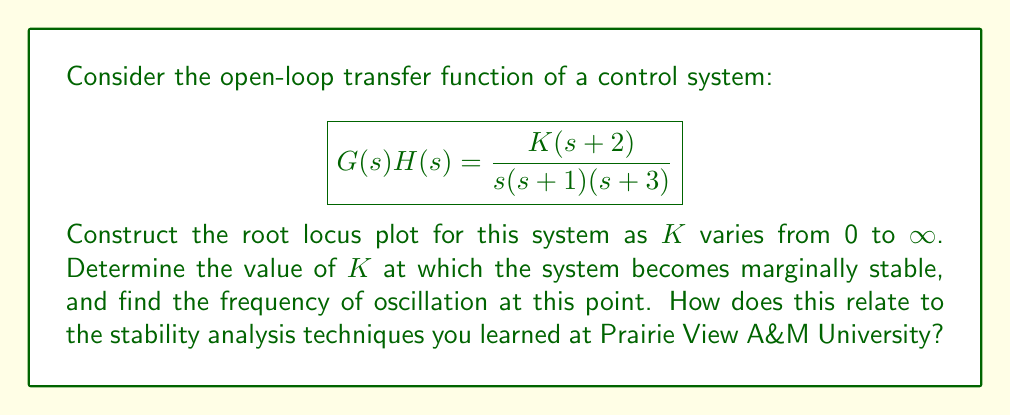Provide a solution to this math problem. To construct the root locus plot and analyze the system behavior, we'll follow these steps:

1. Identify the poles and zeros:
   Poles: s = 0, -1, -3
   Zero: s = -2

2. Determine the number of branches:
   Number of branches = Number of poles = 3

3. Find the root locus on the real axis:
   The root locus exists on the real axis to the left of an odd number of poles and zeros. In this case, it's on the real axis from -∞ to -3, -2 to -1, and 0 to -∞.

4. Calculate the centroid and departure angles:
   Centroid = (-0 - 1 - 3 + 2) / 3 = -4/3
   Departure angles from s = 0: ±90°
   Departure angles from s = -1 and s = -3: 180°

5. Find the breakaway point:
   Set s = -x in the characteristic equation and solve for dK/dx = 0:
   $$K = \frac{x(x+1)(x+3)}{x+2}$$
   $$\frac{dK}{dx} = \frac{(x+1)(x+3)(x+2) + x(x+3)(x+2) + x(x+1)(x+2) - x(x+1)(x+3)}{(x+2)^2} = 0$$
   Solving this equation gives x ≈ 1.5858, so the breakaway point is at s ≈ -1.5858

6. Determine the imaginary axis crossing:
   Use the Routh-Hurwitz criterion to find K at the stability limit:
   Characteristic equation: $s^3 + 4s^2 + (3+K)s + 2K = 0$
   Routh array:
   $$\begin{array}{c|c}
   s^3 & 1 & 3+K \\
   s^2 & 4 & 2K \\
   s^1 & \frac{12+K}{4} & 0 \\
   s^0 & 2K
   \end{array}$$
   
   For marginal stability, $\frac{12+K}{4} = 0$, so K = 12

7. Find the frequency of oscillation:
   At K = 12, the characteristic equation becomes:
   $s^3 + 4s^2 + 15s + 24 = 0$
   The imaginary axis crossing occurs at $s = \pm j\omega$, where $\omega$ is the frequency of oscillation.
   Substituting $s = j\omega$ into the characteristic equation:
   $-j\omega^3 - 4\omega^2 + 15j\omega + 24 = 0$
   Equating real and imaginary parts:
   $-4\omega^2 + 24 = 0$ and $-\omega^3 + 15\omega = 0$
   Solving these equations gives $\omega = \sqrt{6} \approx 2.4495$ rad/s

8. Sketch the root locus plot:
   [asy]
   import graph;
   size(200,200);
   
   xaxis("Re(s)", -4, 1);
   yaxis("Im(s)", -3, 3);
   
   dot((-3,0));
   dot((-2,0));
   dot((-1,0));
   dot((0,0));
   
   draw((-4,0)--(-3,0), blue);
   draw((-2,0)--(-1,0), blue);
   draw((0,0)--(1,0), blue);
   
   path p = (0,0){dir(90)}..(-1.5858,0)..(-3,0);
   draw(p, blue);
   draw(reflect(O,E)*p, blue);
   
   label("$\times$", (-3,0), S);
   label("$\times$", (-1,0), S);
   label("$\times$", (0,0), S);
   label("$\circ$", (-2,0), N);
   [/asy]

This analysis technique is similar to those taught in control systems courses at Prairie View A&M University, emphasizing the importance of root locus plots in understanding system stability and dynamic behavior.
Answer: The system becomes marginally stable when K = 12. At this point, the frequency of oscillation is $\omega = \sqrt{6} \approx 2.4495$ rad/s. 